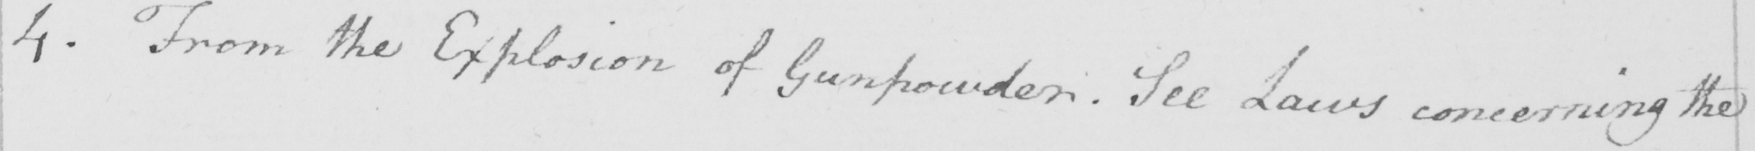Please provide the text content of this handwritten line. 4 . From the Explosion of Gunpowder . See Laws concerning the 